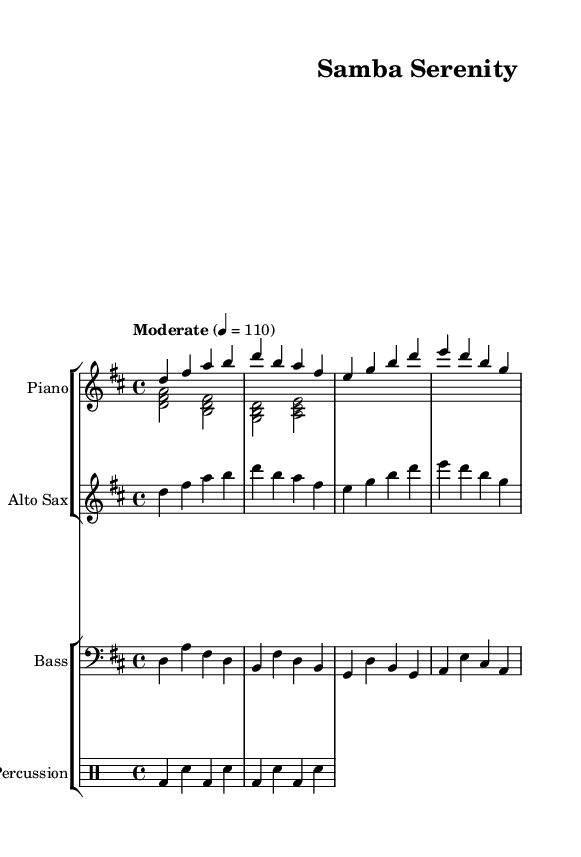What is the key signature of this music? The key signature is indicated at the beginning of the staff. In this case, there are two sharps (F# and C#), indicating that the music is in D major.
Answer: D major What is the time signature of this music? The time signature is displayed after the clef and key signature. Here, the music has a time signature of 4/4, which means there are four beats in a measure and the quarter note gets one beat.
Answer: 4/4 What is the tempo marking for this piece? The tempo marking appears at the start of the score. It states "Moderate" with a metronome marking of 110 beats per minute, indicating a moderately paced performance.
Answer: Moderate 4 = 110 How many instruments are featured in this piece? By analyzing the score, there are a total of four instruments displayed: Piano (with right and left hand parts), Alto Sax, Bass, and Percussion.
Answer: Four What type of rhythm does the percussion section predominantly use? By examining the percussion part, it consists of a simple alternating pattern of bass drum and snare hits in a 4/4 time signature, which is common in Latin music to maintain rhythm and drive.
Answer: Alternating bass and snare What is the range of the Alto Saxophone's part in this piece? The sax part starts from the note D and contains both high and low notes up to the note B. The range of notes covered indicates that it spans over an octave.
Answer: Over an octave What is the function of the bass part in Latin jazz? The bass usually serves to provide harmonic foundation and rhythmic support. In this piece, it plays repeating rhythmic patterns that complement the other instruments, giving depth to the harmony typical in Latin jazz.
Answer: Harmonic foundation and rhythmic support 